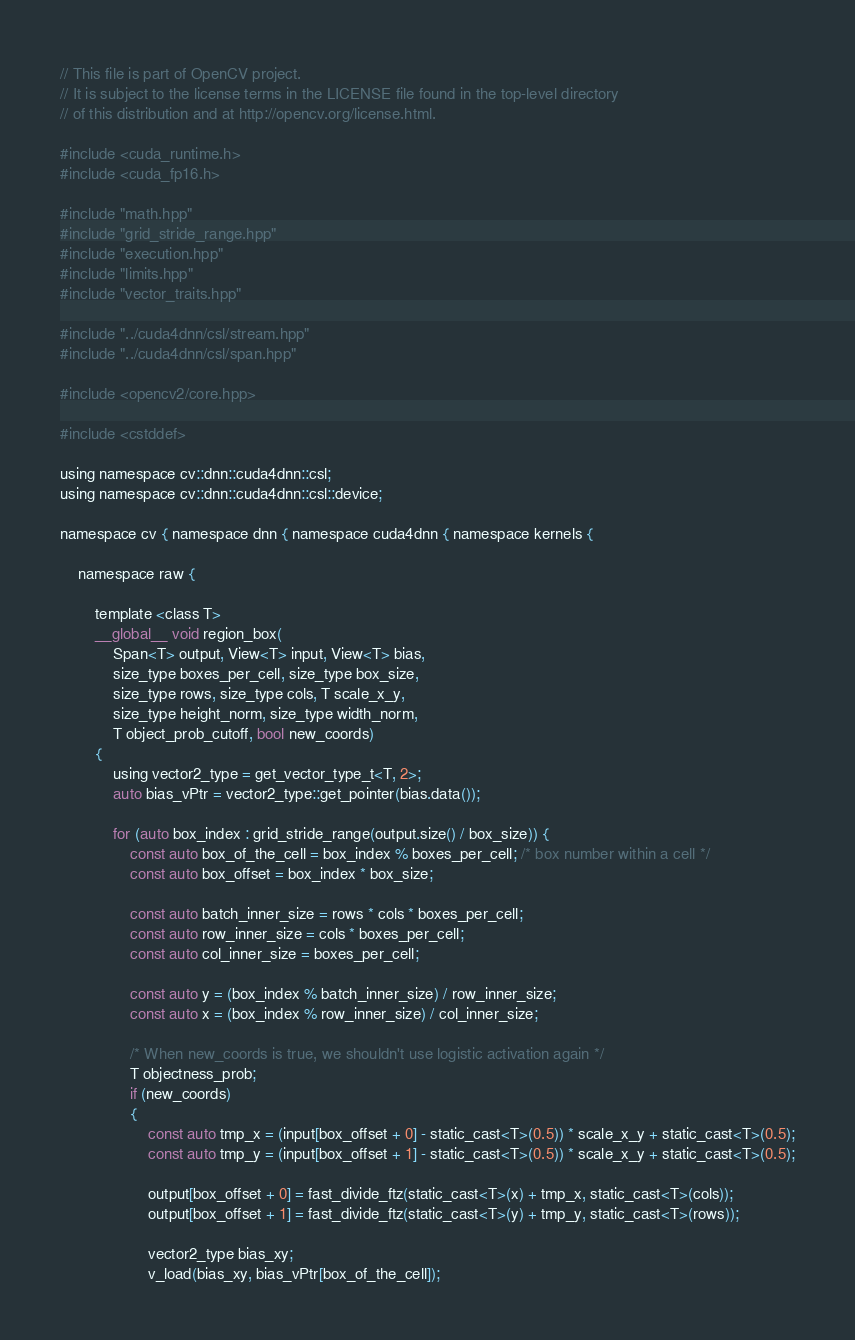Convert code to text. <code><loc_0><loc_0><loc_500><loc_500><_Cuda_>// This file is part of OpenCV project.
// It is subject to the license terms in the LICENSE file found in the top-level directory
// of this distribution and at http://opencv.org/license.html.

#include <cuda_runtime.h>
#include <cuda_fp16.h>

#include "math.hpp"
#include "grid_stride_range.hpp"
#include "execution.hpp"
#include "limits.hpp"
#include "vector_traits.hpp"

#include "../cuda4dnn/csl/stream.hpp"
#include "../cuda4dnn/csl/span.hpp"

#include <opencv2/core.hpp>

#include <cstddef>

using namespace cv::dnn::cuda4dnn::csl;
using namespace cv::dnn::cuda4dnn::csl::device;

namespace cv { namespace dnn { namespace cuda4dnn { namespace kernels {

    namespace raw {

        template <class T>
        __global__ void region_box(
            Span<T> output, View<T> input, View<T> bias,
            size_type boxes_per_cell, size_type box_size,
            size_type rows, size_type cols, T scale_x_y,
            size_type height_norm, size_type width_norm,
            T object_prob_cutoff, bool new_coords)
        {
            using vector2_type = get_vector_type_t<T, 2>;
            auto bias_vPtr = vector2_type::get_pointer(bias.data());

            for (auto box_index : grid_stride_range(output.size() / box_size)) {
                const auto box_of_the_cell = box_index % boxes_per_cell; /* box number within a cell */
                const auto box_offset = box_index * box_size;

                const auto batch_inner_size = rows * cols * boxes_per_cell;
                const auto row_inner_size = cols * boxes_per_cell;
                const auto col_inner_size = boxes_per_cell;

                const auto y = (box_index % batch_inner_size) / row_inner_size;
                const auto x = (box_index % row_inner_size) / col_inner_size;

                /* When new_coords is true, we shouldn't use logistic activation again */
                T objectness_prob;
                if (new_coords)
                {
                    const auto tmp_x = (input[box_offset + 0] - static_cast<T>(0.5)) * scale_x_y + static_cast<T>(0.5);
                    const auto tmp_y = (input[box_offset + 1] - static_cast<T>(0.5)) * scale_x_y + static_cast<T>(0.5);

                    output[box_offset + 0] = fast_divide_ftz(static_cast<T>(x) + tmp_x, static_cast<T>(cols));
                    output[box_offset + 1] = fast_divide_ftz(static_cast<T>(y) + tmp_y, static_cast<T>(rows));

                    vector2_type bias_xy;
                    v_load(bias_xy, bias_vPtr[box_of_the_cell]);
</code> 